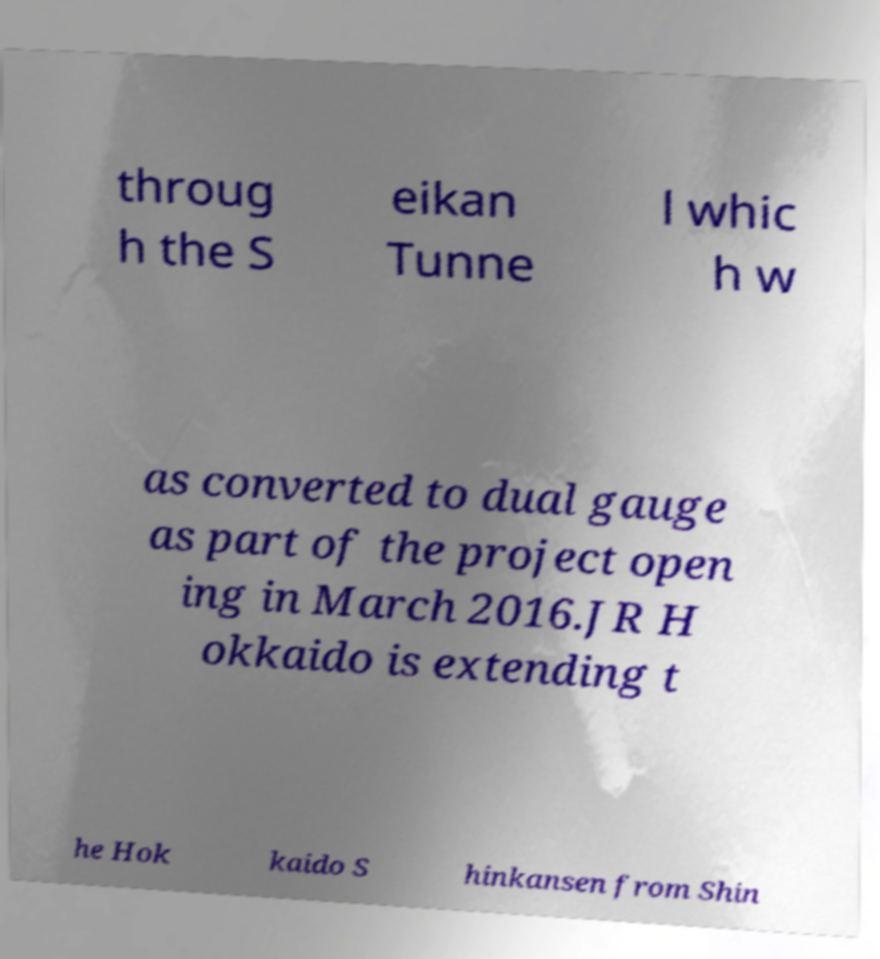There's text embedded in this image that I need extracted. Can you transcribe it verbatim? throug h the S eikan Tunne l whic h w as converted to dual gauge as part of the project open ing in March 2016.JR H okkaido is extending t he Hok kaido S hinkansen from Shin 